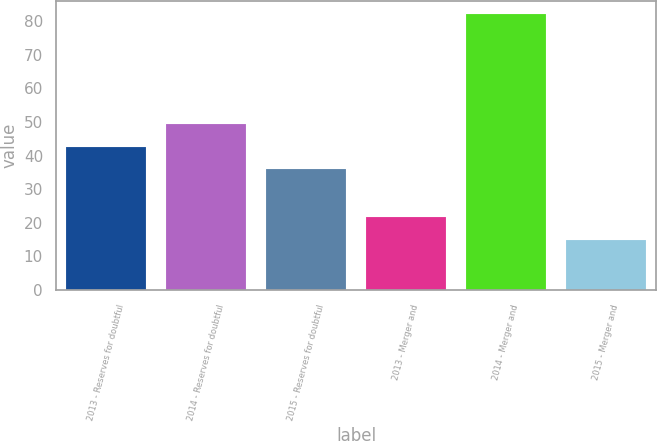Convert chart. <chart><loc_0><loc_0><loc_500><loc_500><bar_chart><fcel>2013 - Reserves for doubtful<fcel>2014 - Reserves for doubtful<fcel>2015 - Reserves for doubtful<fcel>2013 - Merger and<fcel>2014 - Merger and<fcel>2015 - Merger and<nl><fcel>42.7<fcel>49.4<fcel>36<fcel>21.7<fcel>82<fcel>15<nl></chart> 